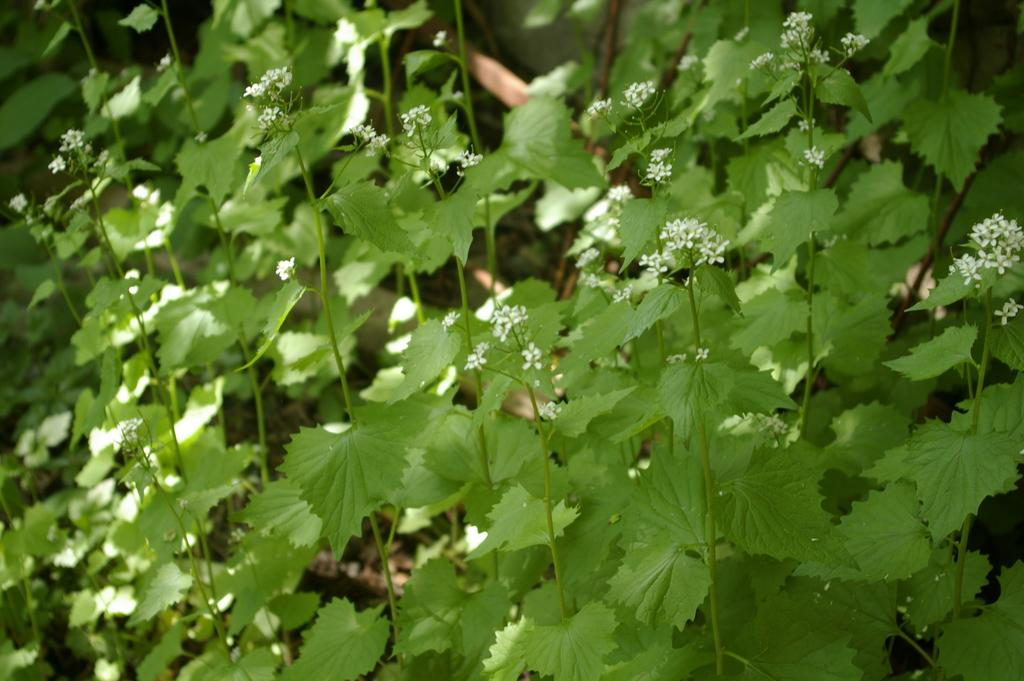What type of living organisms are present in the image? There are many plants in the image. What color are the leaves of the plants? The plants have green leaves. What type of flowers can be seen on the plants? The plants have small white flowers. What type of advice is being given at the airport in the image? There is no airport or advice present in the image; it features plants with green leaves and small white flowers. 